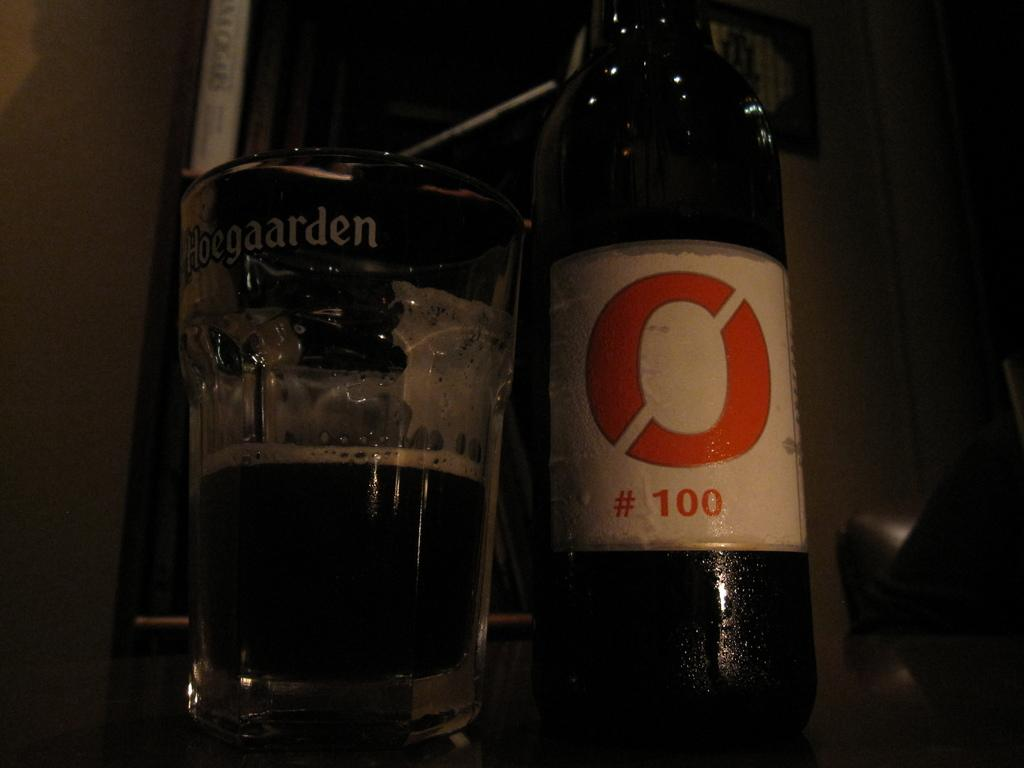<image>
Give a short and clear explanation of the subsequent image. A Hoegaarden glass sits next to a bottle of O # 100 beer 